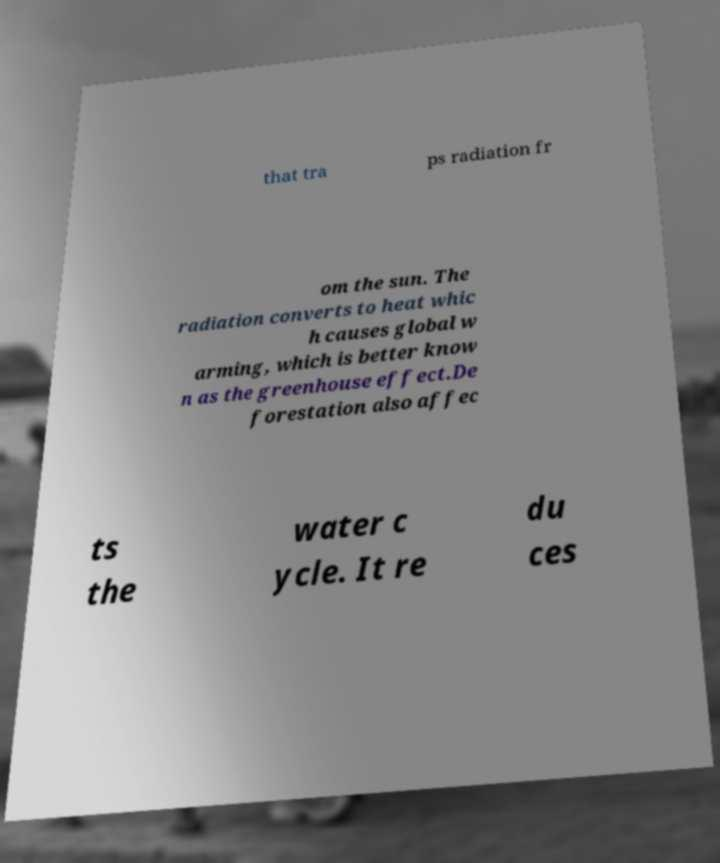Please read and relay the text visible in this image. What does it say? that tra ps radiation fr om the sun. The radiation converts to heat whic h causes global w arming, which is better know n as the greenhouse effect.De forestation also affec ts the water c ycle. It re du ces 